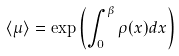<formula> <loc_0><loc_0><loc_500><loc_500>\langle \mu \rangle = \exp \left ( \int _ { 0 } ^ { \beta } \rho ( x ) d x \right )</formula> 